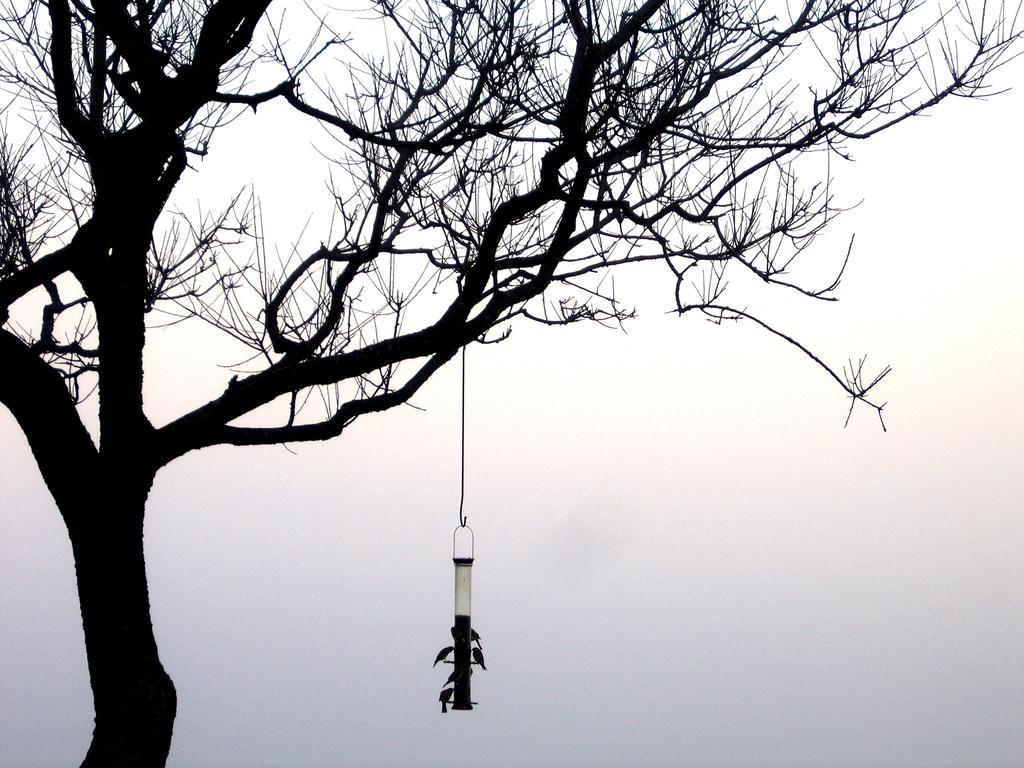Please provide a concise description of this image. In this picture we can see bird feeder hanging to a branch of a tree and we can see birds. In the background of the image we can see the sky. 